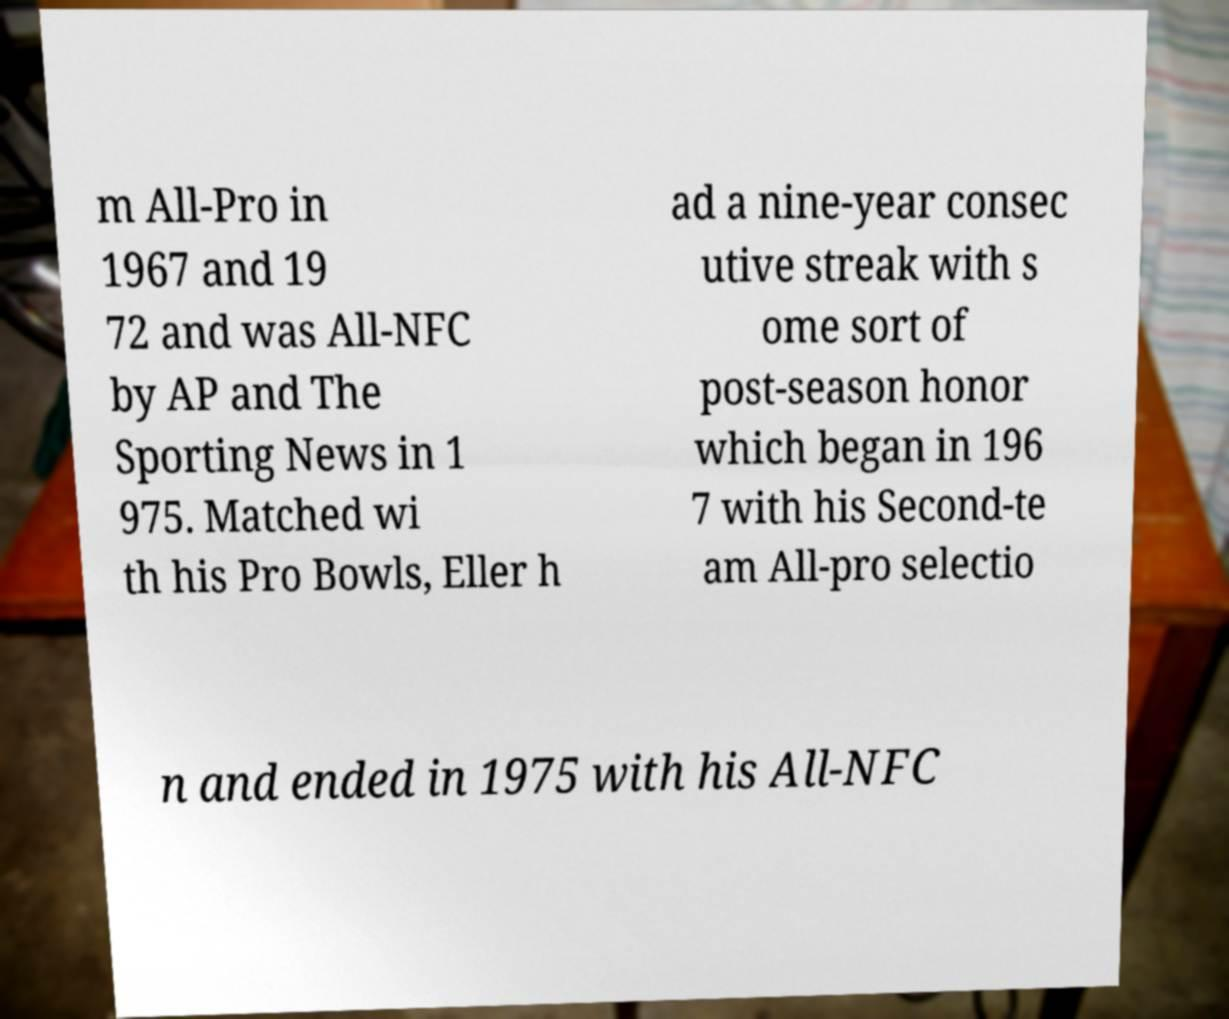Can you read and provide the text displayed in the image?This photo seems to have some interesting text. Can you extract and type it out for me? m All-Pro in 1967 and 19 72 and was All-NFC by AP and The Sporting News in 1 975. Matched wi th his Pro Bowls, Eller h ad a nine-year consec utive streak with s ome sort of post-season honor which began in 196 7 with his Second-te am All-pro selectio n and ended in 1975 with his All-NFC 